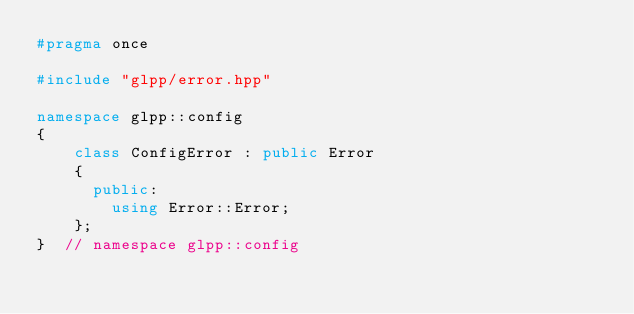Convert code to text. <code><loc_0><loc_0><loc_500><loc_500><_C++_>#pragma once

#include "glpp/error.hpp"

namespace glpp::config
{
    class ConfigError : public Error
    {
      public:
        using Error::Error;
    };
}  // namespace glpp::config</code> 